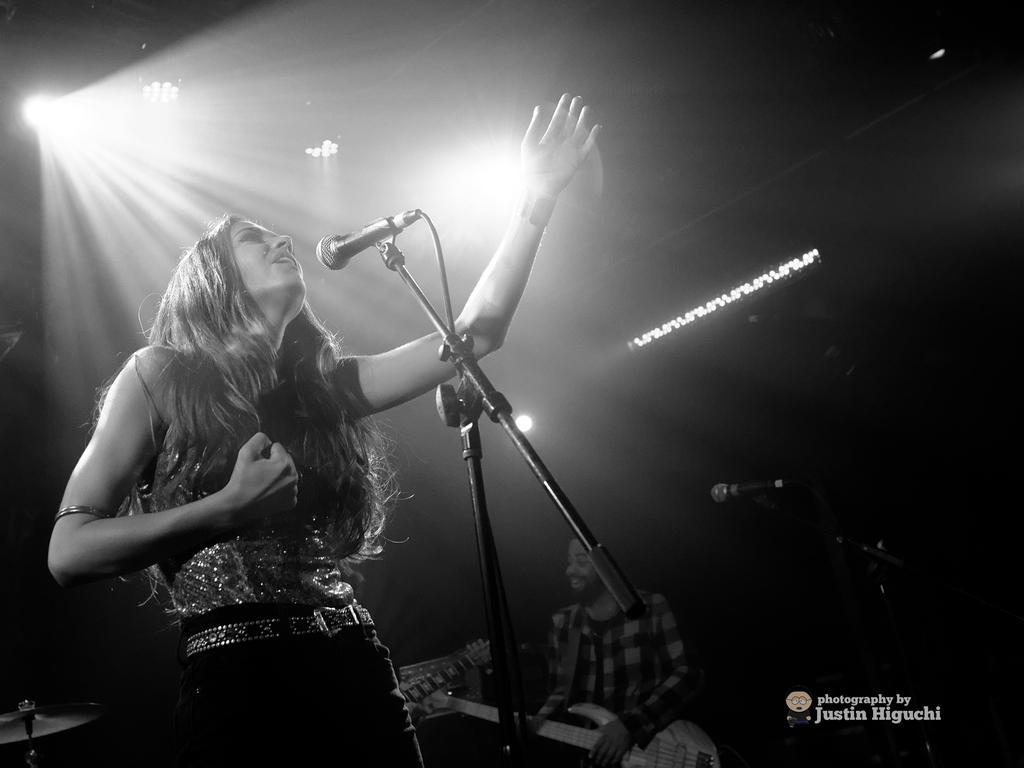Can you describe this image briefly? Here in this picture a lady is standing and singing. In front of her there is a mic and the mic is connected to the mic stand. And to the top left there is light. And to the middle of the picture here is a man sitting and playing guitar and he also singing. To his left hand side there is a mic stand. 